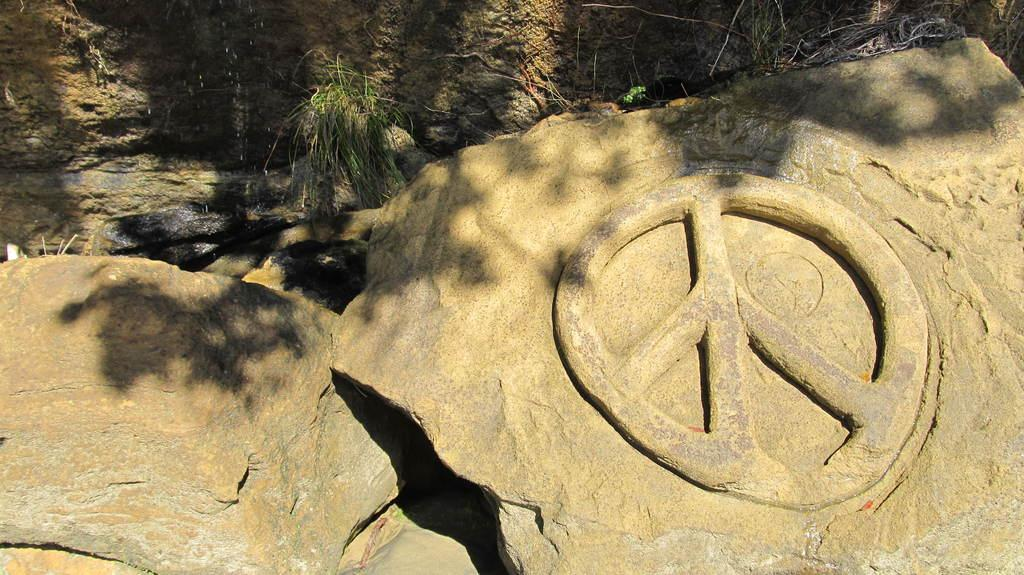What is at the bottom of the image? There are stones at the bottom of the image. Are there any markings on the stones? Yes, there is a symbol engraved on one of the stones. What is at the top of the image? There is another stone with plants and water at the top of the image. What type of brush is being used to paint the flame in the image? There is no flame or brush present in the image. 